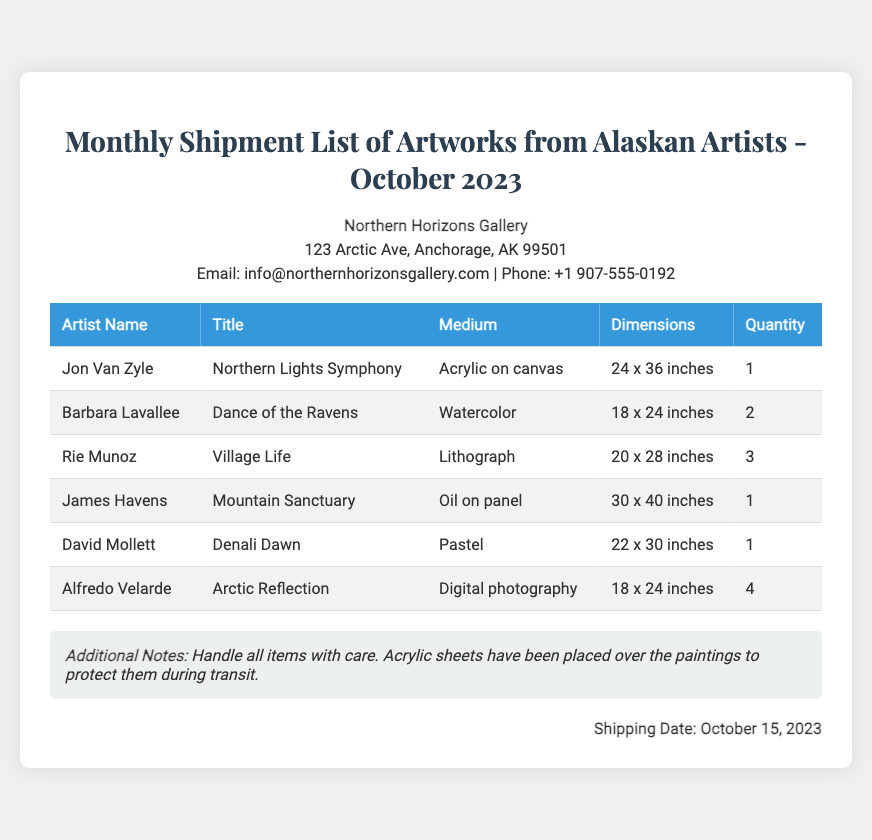What is the title of the artwork by Jon Van Zyle? The title of Jon Van Zyle's artwork is listed in the document under his name.
Answer: Northern Lights Symphony How many artworks are by Barbara Lavallee? The quantity of Barbara Lavallee's artworks can be found in the table next to her name.
Answer: 2 What is the medium of the artwork "Denali Dawn"? The medium for "Denali Dawn" is provided in the document corresponding to David Mollett's entry.
Answer: Pastel Which artist has the highest quantity of artworks? The question asks to compare the quantities of artworks for each artist listed in the document, identifying the artist with the highest number.
Answer: Alfredo Velarde What are the dimensions of "Village Life"? The dimensions for "Village Life" can be found in the corresponding row of Rie Munoz in the document.
Answer: 20 x 28 inches What is the shipping date for the artworks? The shipping date is explicitly mentioned at the bottom of the document.
Answer: October 15, 2023 What type of documentation is this? The document's title and content indicate its nature and purpose.
Answer: Packing list 